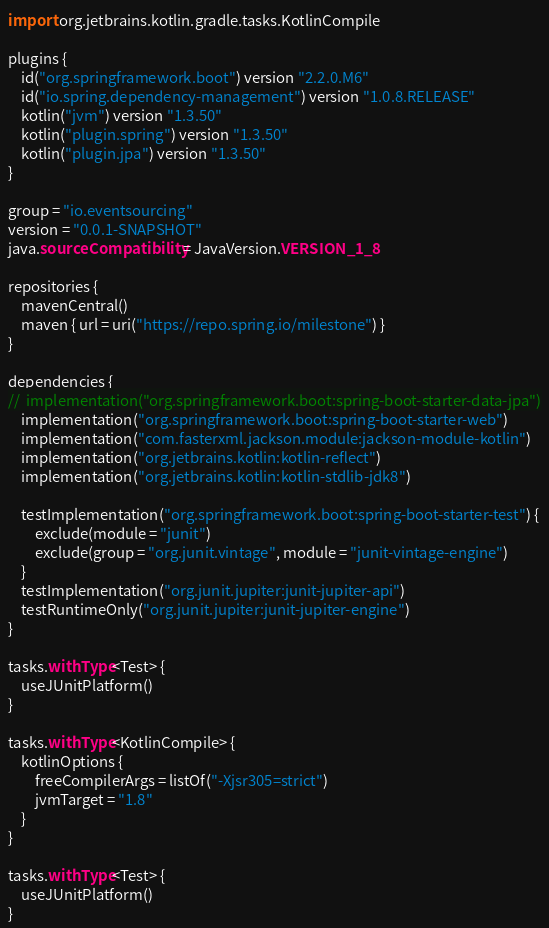Convert code to text. <code><loc_0><loc_0><loc_500><loc_500><_Kotlin_>import org.jetbrains.kotlin.gradle.tasks.KotlinCompile

plugins {
	id("org.springframework.boot") version "2.2.0.M6"
	id("io.spring.dependency-management") version "1.0.8.RELEASE"
	kotlin("jvm") version "1.3.50"
	kotlin("plugin.spring") version "1.3.50"
	kotlin("plugin.jpa") version "1.3.50"
}

group = "io.eventsourcing"
version = "0.0.1-SNAPSHOT"
java.sourceCompatibility = JavaVersion.VERSION_1_8

repositories {
	mavenCentral()
	maven { url = uri("https://repo.spring.io/milestone") }
}

dependencies {
//	implementation("org.springframework.boot:spring-boot-starter-data-jpa")
	implementation("org.springframework.boot:spring-boot-starter-web")
	implementation("com.fasterxml.jackson.module:jackson-module-kotlin")
	implementation("org.jetbrains.kotlin:kotlin-reflect")
	implementation("org.jetbrains.kotlin:kotlin-stdlib-jdk8")

	testImplementation("org.springframework.boot:spring-boot-starter-test") {
		exclude(module = "junit")
		exclude(group = "org.junit.vintage", module = "junit-vintage-engine")
	}
	testImplementation("org.junit.jupiter:junit-jupiter-api")
	testRuntimeOnly("org.junit.jupiter:junit-jupiter-engine")
}

tasks.withType<Test> {
	useJUnitPlatform()
}

tasks.withType<KotlinCompile> {
	kotlinOptions {
		freeCompilerArgs = listOf("-Xjsr305=strict")
		jvmTarget = "1.8"
	}
}

tasks.withType<Test> {
	useJUnitPlatform()
}</code> 